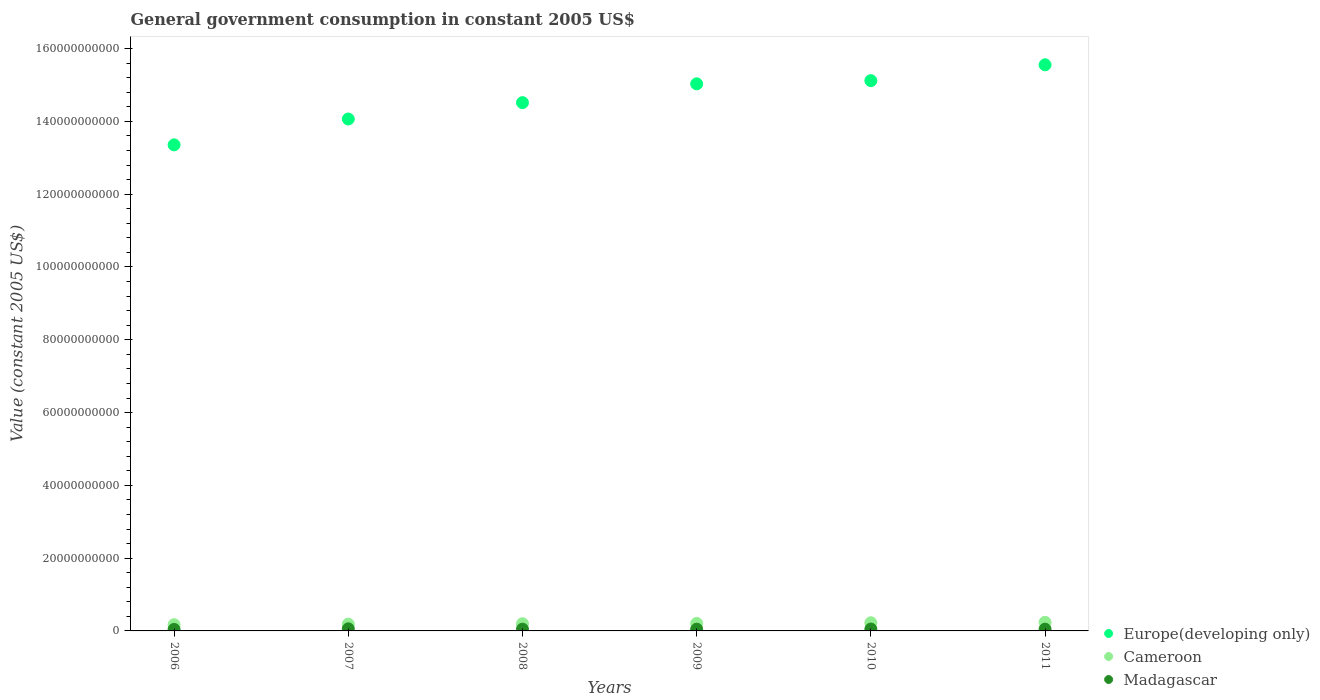Is the number of dotlines equal to the number of legend labels?
Make the answer very short. Yes. What is the government conusmption in Cameroon in 2011?
Offer a very short reply. 2.36e+09. Across all years, what is the maximum government conusmption in Madagascar?
Ensure brevity in your answer.  5.80e+08. Across all years, what is the minimum government conusmption in Cameroon?
Provide a short and direct response. 1.70e+09. What is the total government conusmption in Europe(developing only) in the graph?
Your answer should be very brief. 8.76e+11. What is the difference between the government conusmption in Cameroon in 2007 and that in 2008?
Your response must be concise. -1.17e+08. What is the difference between the government conusmption in Cameroon in 2006 and the government conusmption in Europe(developing only) in 2007?
Your answer should be compact. -1.39e+11. What is the average government conusmption in Cameroon per year?
Your answer should be very brief. 2.03e+09. In the year 2008, what is the difference between the government conusmption in Europe(developing only) and government conusmption in Cameroon?
Provide a short and direct response. 1.43e+11. What is the ratio of the government conusmption in Cameroon in 2007 to that in 2010?
Offer a terse response. 0.83. Is the government conusmption in Madagascar in 2008 less than that in 2010?
Your answer should be very brief. Yes. Is the difference between the government conusmption in Europe(developing only) in 2009 and 2010 greater than the difference between the government conusmption in Cameroon in 2009 and 2010?
Offer a very short reply. No. What is the difference between the highest and the second highest government conusmption in Cameroon?
Your response must be concise. 1.22e+08. What is the difference between the highest and the lowest government conusmption in Cameroon?
Ensure brevity in your answer.  6.59e+08. Is the sum of the government conusmption in Cameroon in 2006 and 2008 greater than the maximum government conusmption in Madagascar across all years?
Ensure brevity in your answer.  Yes. Does the government conusmption in Europe(developing only) monotonically increase over the years?
Give a very brief answer. Yes. Is the government conusmption in Cameroon strictly greater than the government conusmption in Europe(developing only) over the years?
Offer a terse response. No. Is the government conusmption in Cameroon strictly less than the government conusmption in Europe(developing only) over the years?
Make the answer very short. Yes. Are the values on the major ticks of Y-axis written in scientific E-notation?
Provide a succinct answer. No. What is the title of the graph?
Your response must be concise. General government consumption in constant 2005 US$. Does "Faeroe Islands" appear as one of the legend labels in the graph?
Provide a short and direct response. No. What is the label or title of the Y-axis?
Ensure brevity in your answer.  Value (constant 2005 US$). What is the Value (constant 2005 US$) of Europe(developing only) in 2006?
Keep it short and to the point. 1.34e+11. What is the Value (constant 2005 US$) in Cameroon in 2006?
Your response must be concise. 1.70e+09. What is the Value (constant 2005 US$) of Madagascar in 2006?
Ensure brevity in your answer.  4.10e+08. What is the Value (constant 2005 US$) of Europe(developing only) in 2007?
Provide a succinct answer. 1.41e+11. What is the Value (constant 2005 US$) of Cameroon in 2007?
Your answer should be compact. 1.86e+09. What is the Value (constant 2005 US$) in Madagascar in 2007?
Give a very brief answer. 5.80e+08. What is the Value (constant 2005 US$) of Europe(developing only) in 2008?
Keep it short and to the point. 1.45e+11. What is the Value (constant 2005 US$) of Cameroon in 2008?
Offer a terse response. 1.97e+09. What is the Value (constant 2005 US$) of Madagascar in 2008?
Provide a short and direct response. 4.82e+08. What is the Value (constant 2005 US$) of Europe(developing only) in 2009?
Ensure brevity in your answer.  1.50e+11. What is the Value (constant 2005 US$) in Cameroon in 2009?
Provide a short and direct response. 2.07e+09. What is the Value (constant 2005 US$) in Madagascar in 2009?
Your response must be concise. 4.81e+08. What is the Value (constant 2005 US$) in Europe(developing only) in 2010?
Make the answer very short. 1.51e+11. What is the Value (constant 2005 US$) of Cameroon in 2010?
Offer a very short reply. 2.24e+09. What is the Value (constant 2005 US$) in Madagascar in 2010?
Provide a short and direct response. 5.17e+08. What is the Value (constant 2005 US$) in Europe(developing only) in 2011?
Your answer should be very brief. 1.56e+11. What is the Value (constant 2005 US$) in Cameroon in 2011?
Your response must be concise. 2.36e+09. What is the Value (constant 2005 US$) in Madagascar in 2011?
Offer a terse response. 4.89e+08. Across all years, what is the maximum Value (constant 2005 US$) of Europe(developing only)?
Provide a short and direct response. 1.56e+11. Across all years, what is the maximum Value (constant 2005 US$) in Cameroon?
Your answer should be very brief. 2.36e+09. Across all years, what is the maximum Value (constant 2005 US$) of Madagascar?
Give a very brief answer. 5.80e+08. Across all years, what is the minimum Value (constant 2005 US$) of Europe(developing only)?
Offer a terse response. 1.34e+11. Across all years, what is the minimum Value (constant 2005 US$) in Cameroon?
Your answer should be very brief. 1.70e+09. Across all years, what is the minimum Value (constant 2005 US$) in Madagascar?
Keep it short and to the point. 4.10e+08. What is the total Value (constant 2005 US$) in Europe(developing only) in the graph?
Your answer should be very brief. 8.76e+11. What is the total Value (constant 2005 US$) of Cameroon in the graph?
Your response must be concise. 1.22e+1. What is the total Value (constant 2005 US$) of Madagascar in the graph?
Your answer should be compact. 2.96e+09. What is the difference between the Value (constant 2005 US$) of Europe(developing only) in 2006 and that in 2007?
Offer a terse response. -7.10e+09. What is the difference between the Value (constant 2005 US$) of Cameroon in 2006 and that in 2007?
Make the answer very short. -1.54e+08. What is the difference between the Value (constant 2005 US$) of Madagascar in 2006 and that in 2007?
Keep it short and to the point. -1.70e+08. What is the difference between the Value (constant 2005 US$) of Europe(developing only) in 2006 and that in 2008?
Your answer should be very brief. -1.16e+1. What is the difference between the Value (constant 2005 US$) in Cameroon in 2006 and that in 2008?
Your answer should be very brief. -2.72e+08. What is the difference between the Value (constant 2005 US$) of Madagascar in 2006 and that in 2008?
Your answer should be compact. -7.20e+07. What is the difference between the Value (constant 2005 US$) in Europe(developing only) in 2006 and that in 2009?
Your response must be concise. -1.68e+1. What is the difference between the Value (constant 2005 US$) of Cameroon in 2006 and that in 2009?
Ensure brevity in your answer.  -3.63e+08. What is the difference between the Value (constant 2005 US$) in Madagascar in 2006 and that in 2009?
Your answer should be very brief. -7.07e+07. What is the difference between the Value (constant 2005 US$) of Europe(developing only) in 2006 and that in 2010?
Your response must be concise. -1.76e+1. What is the difference between the Value (constant 2005 US$) in Cameroon in 2006 and that in 2010?
Give a very brief answer. -5.36e+08. What is the difference between the Value (constant 2005 US$) of Madagascar in 2006 and that in 2010?
Give a very brief answer. -1.07e+08. What is the difference between the Value (constant 2005 US$) in Europe(developing only) in 2006 and that in 2011?
Give a very brief answer. -2.20e+1. What is the difference between the Value (constant 2005 US$) in Cameroon in 2006 and that in 2011?
Make the answer very short. -6.59e+08. What is the difference between the Value (constant 2005 US$) of Madagascar in 2006 and that in 2011?
Ensure brevity in your answer.  -7.88e+07. What is the difference between the Value (constant 2005 US$) of Europe(developing only) in 2007 and that in 2008?
Your response must be concise. -4.50e+09. What is the difference between the Value (constant 2005 US$) of Cameroon in 2007 and that in 2008?
Provide a short and direct response. -1.17e+08. What is the difference between the Value (constant 2005 US$) of Madagascar in 2007 and that in 2008?
Your response must be concise. 9.81e+07. What is the difference between the Value (constant 2005 US$) of Europe(developing only) in 2007 and that in 2009?
Offer a terse response. -9.67e+09. What is the difference between the Value (constant 2005 US$) in Cameroon in 2007 and that in 2009?
Your answer should be compact. -2.09e+08. What is the difference between the Value (constant 2005 US$) in Madagascar in 2007 and that in 2009?
Keep it short and to the point. 9.94e+07. What is the difference between the Value (constant 2005 US$) of Europe(developing only) in 2007 and that in 2010?
Keep it short and to the point. -1.05e+1. What is the difference between the Value (constant 2005 US$) in Cameroon in 2007 and that in 2010?
Offer a very short reply. -3.82e+08. What is the difference between the Value (constant 2005 US$) in Madagascar in 2007 and that in 2010?
Give a very brief answer. 6.27e+07. What is the difference between the Value (constant 2005 US$) of Europe(developing only) in 2007 and that in 2011?
Give a very brief answer. -1.49e+1. What is the difference between the Value (constant 2005 US$) in Cameroon in 2007 and that in 2011?
Offer a very short reply. -5.04e+08. What is the difference between the Value (constant 2005 US$) in Madagascar in 2007 and that in 2011?
Your answer should be compact. 9.14e+07. What is the difference between the Value (constant 2005 US$) of Europe(developing only) in 2008 and that in 2009?
Ensure brevity in your answer.  -5.17e+09. What is the difference between the Value (constant 2005 US$) in Cameroon in 2008 and that in 2009?
Your answer should be compact. -9.13e+07. What is the difference between the Value (constant 2005 US$) of Madagascar in 2008 and that in 2009?
Keep it short and to the point. 1.31e+06. What is the difference between the Value (constant 2005 US$) of Europe(developing only) in 2008 and that in 2010?
Give a very brief answer. -6.04e+09. What is the difference between the Value (constant 2005 US$) of Cameroon in 2008 and that in 2010?
Provide a succinct answer. -2.65e+08. What is the difference between the Value (constant 2005 US$) in Madagascar in 2008 and that in 2010?
Your answer should be compact. -3.54e+07. What is the difference between the Value (constant 2005 US$) in Europe(developing only) in 2008 and that in 2011?
Keep it short and to the point. -1.04e+1. What is the difference between the Value (constant 2005 US$) of Cameroon in 2008 and that in 2011?
Your answer should be very brief. -3.87e+08. What is the difference between the Value (constant 2005 US$) of Madagascar in 2008 and that in 2011?
Provide a short and direct response. -6.71e+06. What is the difference between the Value (constant 2005 US$) in Europe(developing only) in 2009 and that in 2010?
Your answer should be compact. -8.73e+08. What is the difference between the Value (constant 2005 US$) of Cameroon in 2009 and that in 2010?
Your answer should be very brief. -1.73e+08. What is the difference between the Value (constant 2005 US$) of Madagascar in 2009 and that in 2010?
Provide a short and direct response. -3.68e+07. What is the difference between the Value (constant 2005 US$) in Europe(developing only) in 2009 and that in 2011?
Ensure brevity in your answer.  -5.23e+09. What is the difference between the Value (constant 2005 US$) in Cameroon in 2009 and that in 2011?
Provide a succinct answer. -2.96e+08. What is the difference between the Value (constant 2005 US$) of Madagascar in 2009 and that in 2011?
Make the answer very short. -8.02e+06. What is the difference between the Value (constant 2005 US$) in Europe(developing only) in 2010 and that in 2011?
Offer a terse response. -4.36e+09. What is the difference between the Value (constant 2005 US$) of Cameroon in 2010 and that in 2011?
Make the answer very short. -1.22e+08. What is the difference between the Value (constant 2005 US$) of Madagascar in 2010 and that in 2011?
Make the answer very short. 2.87e+07. What is the difference between the Value (constant 2005 US$) of Europe(developing only) in 2006 and the Value (constant 2005 US$) of Cameroon in 2007?
Ensure brevity in your answer.  1.32e+11. What is the difference between the Value (constant 2005 US$) in Europe(developing only) in 2006 and the Value (constant 2005 US$) in Madagascar in 2007?
Give a very brief answer. 1.33e+11. What is the difference between the Value (constant 2005 US$) in Cameroon in 2006 and the Value (constant 2005 US$) in Madagascar in 2007?
Make the answer very short. 1.12e+09. What is the difference between the Value (constant 2005 US$) of Europe(developing only) in 2006 and the Value (constant 2005 US$) of Cameroon in 2008?
Your response must be concise. 1.32e+11. What is the difference between the Value (constant 2005 US$) in Europe(developing only) in 2006 and the Value (constant 2005 US$) in Madagascar in 2008?
Keep it short and to the point. 1.33e+11. What is the difference between the Value (constant 2005 US$) in Cameroon in 2006 and the Value (constant 2005 US$) in Madagascar in 2008?
Your answer should be compact. 1.22e+09. What is the difference between the Value (constant 2005 US$) of Europe(developing only) in 2006 and the Value (constant 2005 US$) of Cameroon in 2009?
Offer a terse response. 1.31e+11. What is the difference between the Value (constant 2005 US$) in Europe(developing only) in 2006 and the Value (constant 2005 US$) in Madagascar in 2009?
Make the answer very short. 1.33e+11. What is the difference between the Value (constant 2005 US$) of Cameroon in 2006 and the Value (constant 2005 US$) of Madagascar in 2009?
Give a very brief answer. 1.22e+09. What is the difference between the Value (constant 2005 US$) in Europe(developing only) in 2006 and the Value (constant 2005 US$) in Cameroon in 2010?
Ensure brevity in your answer.  1.31e+11. What is the difference between the Value (constant 2005 US$) in Europe(developing only) in 2006 and the Value (constant 2005 US$) in Madagascar in 2010?
Offer a terse response. 1.33e+11. What is the difference between the Value (constant 2005 US$) in Cameroon in 2006 and the Value (constant 2005 US$) in Madagascar in 2010?
Offer a terse response. 1.18e+09. What is the difference between the Value (constant 2005 US$) in Europe(developing only) in 2006 and the Value (constant 2005 US$) in Cameroon in 2011?
Provide a short and direct response. 1.31e+11. What is the difference between the Value (constant 2005 US$) of Europe(developing only) in 2006 and the Value (constant 2005 US$) of Madagascar in 2011?
Offer a terse response. 1.33e+11. What is the difference between the Value (constant 2005 US$) of Cameroon in 2006 and the Value (constant 2005 US$) of Madagascar in 2011?
Make the answer very short. 1.21e+09. What is the difference between the Value (constant 2005 US$) of Europe(developing only) in 2007 and the Value (constant 2005 US$) of Cameroon in 2008?
Provide a succinct answer. 1.39e+11. What is the difference between the Value (constant 2005 US$) in Europe(developing only) in 2007 and the Value (constant 2005 US$) in Madagascar in 2008?
Ensure brevity in your answer.  1.40e+11. What is the difference between the Value (constant 2005 US$) of Cameroon in 2007 and the Value (constant 2005 US$) of Madagascar in 2008?
Ensure brevity in your answer.  1.37e+09. What is the difference between the Value (constant 2005 US$) in Europe(developing only) in 2007 and the Value (constant 2005 US$) in Cameroon in 2009?
Your answer should be very brief. 1.39e+11. What is the difference between the Value (constant 2005 US$) of Europe(developing only) in 2007 and the Value (constant 2005 US$) of Madagascar in 2009?
Offer a very short reply. 1.40e+11. What is the difference between the Value (constant 2005 US$) of Cameroon in 2007 and the Value (constant 2005 US$) of Madagascar in 2009?
Your answer should be very brief. 1.38e+09. What is the difference between the Value (constant 2005 US$) in Europe(developing only) in 2007 and the Value (constant 2005 US$) in Cameroon in 2010?
Your answer should be compact. 1.38e+11. What is the difference between the Value (constant 2005 US$) of Europe(developing only) in 2007 and the Value (constant 2005 US$) of Madagascar in 2010?
Offer a very short reply. 1.40e+11. What is the difference between the Value (constant 2005 US$) of Cameroon in 2007 and the Value (constant 2005 US$) of Madagascar in 2010?
Your response must be concise. 1.34e+09. What is the difference between the Value (constant 2005 US$) in Europe(developing only) in 2007 and the Value (constant 2005 US$) in Cameroon in 2011?
Your response must be concise. 1.38e+11. What is the difference between the Value (constant 2005 US$) of Europe(developing only) in 2007 and the Value (constant 2005 US$) of Madagascar in 2011?
Offer a terse response. 1.40e+11. What is the difference between the Value (constant 2005 US$) of Cameroon in 2007 and the Value (constant 2005 US$) of Madagascar in 2011?
Ensure brevity in your answer.  1.37e+09. What is the difference between the Value (constant 2005 US$) of Europe(developing only) in 2008 and the Value (constant 2005 US$) of Cameroon in 2009?
Ensure brevity in your answer.  1.43e+11. What is the difference between the Value (constant 2005 US$) in Europe(developing only) in 2008 and the Value (constant 2005 US$) in Madagascar in 2009?
Your answer should be very brief. 1.45e+11. What is the difference between the Value (constant 2005 US$) in Cameroon in 2008 and the Value (constant 2005 US$) in Madagascar in 2009?
Keep it short and to the point. 1.49e+09. What is the difference between the Value (constant 2005 US$) in Europe(developing only) in 2008 and the Value (constant 2005 US$) in Cameroon in 2010?
Offer a very short reply. 1.43e+11. What is the difference between the Value (constant 2005 US$) of Europe(developing only) in 2008 and the Value (constant 2005 US$) of Madagascar in 2010?
Give a very brief answer. 1.45e+11. What is the difference between the Value (constant 2005 US$) in Cameroon in 2008 and the Value (constant 2005 US$) in Madagascar in 2010?
Offer a terse response. 1.46e+09. What is the difference between the Value (constant 2005 US$) of Europe(developing only) in 2008 and the Value (constant 2005 US$) of Cameroon in 2011?
Make the answer very short. 1.43e+11. What is the difference between the Value (constant 2005 US$) in Europe(developing only) in 2008 and the Value (constant 2005 US$) in Madagascar in 2011?
Provide a short and direct response. 1.45e+11. What is the difference between the Value (constant 2005 US$) in Cameroon in 2008 and the Value (constant 2005 US$) in Madagascar in 2011?
Offer a very short reply. 1.49e+09. What is the difference between the Value (constant 2005 US$) in Europe(developing only) in 2009 and the Value (constant 2005 US$) in Cameroon in 2010?
Provide a short and direct response. 1.48e+11. What is the difference between the Value (constant 2005 US$) of Europe(developing only) in 2009 and the Value (constant 2005 US$) of Madagascar in 2010?
Offer a very short reply. 1.50e+11. What is the difference between the Value (constant 2005 US$) of Cameroon in 2009 and the Value (constant 2005 US$) of Madagascar in 2010?
Make the answer very short. 1.55e+09. What is the difference between the Value (constant 2005 US$) in Europe(developing only) in 2009 and the Value (constant 2005 US$) in Cameroon in 2011?
Your answer should be compact. 1.48e+11. What is the difference between the Value (constant 2005 US$) in Europe(developing only) in 2009 and the Value (constant 2005 US$) in Madagascar in 2011?
Offer a very short reply. 1.50e+11. What is the difference between the Value (constant 2005 US$) of Cameroon in 2009 and the Value (constant 2005 US$) of Madagascar in 2011?
Ensure brevity in your answer.  1.58e+09. What is the difference between the Value (constant 2005 US$) in Europe(developing only) in 2010 and the Value (constant 2005 US$) in Cameroon in 2011?
Provide a short and direct response. 1.49e+11. What is the difference between the Value (constant 2005 US$) of Europe(developing only) in 2010 and the Value (constant 2005 US$) of Madagascar in 2011?
Provide a short and direct response. 1.51e+11. What is the difference between the Value (constant 2005 US$) in Cameroon in 2010 and the Value (constant 2005 US$) in Madagascar in 2011?
Ensure brevity in your answer.  1.75e+09. What is the average Value (constant 2005 US$) of Europe(developing only) per year?
Make the answer very short. 1.46e+11. What is the average Value (constant 2005 US$) in Cameroon per year?
Give a very brief answer. 2.03e+09. What is the average Value (constant 2005 US$) of Madagascar per year?
Make the answer very short. 4.93e+08. In the year 2006, what is the difference between the Value (constant 2005 US$) in Europe(developing only) and Value (constant 2005 US$) in Cameroon?
Provide a succinct answer. 1.32e+11. In the year 2006, what is the difference between the Value (constant 2005 US$) of Europe(developing only) and Value (constant 2005 US$) of Madagascar?
Your response must be concise. 1.33e+11. In the year 2006, what is the difference between the Value (constant 2005 US$) in Cameroon and Value (constant 2005 US$) in Madagascar?
Keep it short and to the point. 1.29e+09. In the year 2007, what is the difference between the Value (constant 2005 US$) in Europe(developing only) and Value (constant 2005 US$) in Cameroon?
Your answer should be very brief. 1.39e+11. In the year 2007, what is the difference between the Value (constant 2005 US$) in Europe(developing only) and Value (constant 2005 US$) in Madagascar?
Your answer should be compact. 1.40e+11. In the year 2007, what is the difference between the Value (constant 2005 US$) of Cameroon and Value (constant 2005 US$) of Madagascar?
Your response must be concise. 1.28e+09. In the year 2008, what is the difference between the Value (constant 2005 US$) in Europe(developing only) and Value (constant 2005 US$) in Cameroon?
Offer a very short reply. 1.43e+11. In the year 2008, what is the difference between the Value (constant 2005 US$) of Europe(developing only) and Value (constant 2005 US$) of Madagascar?
Give a very brief answer. 1.45e+11. In the year 2008, what is the difference between the Value (constant 2005 US$) of Cameroon and Value (constant 2005 US$) of Madagascar?
Keep it short and to the point. 1.49e+09. In the year 2009, what is the difference between the Value (constant 2005 US$) in Europe(developing only) and Value (constant 2005 US$) in Cameroon?
Keep it short and to the point. 1.48e+11. In the year 2009, what is the difference between the Value (constant 2005 US$) in Europe(developing only) and Value (constant 2005 US$) in Madagascar?
Provide a short and direct response. 1.50e+11. In the year 2009, what is the difference between the Value (constant 2005 US$) in Cameroon and Value (constant 2005 US$) in Madagascar?
Ensure brevity in your answer.  1.58e+09. In the year 2010, what is the difference between the Value (constant 2005 US$) in Europe(developing only) and Value (constant 2005 US$) in Cameroon?
Your response must be concise. 1.49e+11. In the year 2010, what is the difference between the Value (constant 2005 US$) of Europe(developing only) and Value (constant 2005 US$) of Madagascar?
Provide a succinct answer. 1.51e+11. In the year 2010, what is the difference between the Value (constant 2005 US$) of Cameroon and Value (constant 2005 US$) of Madagascar?
Give a very brief answer. 1.72e+09. In the year 2011, what is the difference between the Value (constant 2005 US$) in Europe(developing only) and Value (constant 2005 US$) in Cameroon?
Offer a terse response. 1.53e+11. In the year 2011, what is the difference between the Value (constant 2005 US$) of Europe(developing only) and Value (constant 2005 US$) of Madagascar?
Provide a short and direct response. 1.55e+11. In the year 2011, what is the difference between the Value (constant 2005 US$) of Cameroon and Value (constant 2005 US$) of Madagascar?
Your response must be concise. 1.87e+09. What is the ratio of the Value (constant 2005 US$) of Europe(developing only) in 2006 to that in 2007?
Provide a succinct answer. 0.95. What is the ratio of the Value (constant 2005 US$) of Cameroon in 2006 to that in 2007?
Your answer should be compact. 0.92. What is the ratio of the Value (constant 2005 US$) of Madagascar in 2006 to that in 2007?
Your answer should be very brief. 0.71. What is the ratio of the Value (constant 2005 US$) in Europe(developing only) in 2006 to that in 2008?
Your answer should be compact. 0.92. What is the ratio of the Value (constant 2005 US$) of Cameroon in 2006 to that in 2008?
Your answer should be very brief. 0.86. What is the ratio of the Value (constant 2005 US$) in Madagascar in 2006 to that in 2008?
Ensure brevity in your answer.  0.85. What is the ratio of the Value (constant 2005 US$) in Europe(developing only) in 2006 to that in 2009?
Provide a succinct answer. 0.89. What is the ratio of the Value (constant 2005 US$) in Cameroon in 2006 to that in 2009?
Provide a succinct answer. 0.82. What is the ratio of the Value (constant 2005 US$) in Madagascar in 2006 to that in 2009?
Give a very brief answer. 0.85. What is the ratio of the Value (constant 2005 US$) of Europe(developing only) in 2006 to that in 2010?
Your answer should be very brief. 0.88. What is the ratio of the Value (constant 2005 US$) of Cameroon in 2006 to that in 2010?
Offer a very short reply. 0.76. What is the ratio of the Value (constant 2005 US$) of Madagascar in 2006 to that in 2010?
Ensure brevity in your answer.  0.79. What is the ratio of the Value (constant 2005 US$) in Europe(developing only) in 2006 to that in 2011?
Provide a short and direct response. 0.86. What is the ratio of the Value (constant 2005 US$) in Cameroon in 2006 to that in 2011?
Make the answer very short. 0.72. What is the ratio of the Value (constant 2005 US$) of Madagascar in 2006 to that in 2011?
Your response must be concise. 0.84. What is the ratio of the Value (constant 2005 US$) of Cameroon in 2007 to that in 2008?
Provide a succinct answer. 0.94. What is the ratio of the Value (constant 2005 US$) in Madagascar in 2007 to that in 2008?
Give a very brief answer. 1.2. What is the ratio of the Value (constant 2005 US$) in Europe(developing only) in 2007 to that in 2009?
Make the answer very short. 0.94. What is the ratio of the Value (constant 2005 US$) of Cameroon in 2007 to that in 2009?
Ensure brevity in your answer.  0.9. What is the ratio of the Value (constant 2005 US$) of Madagascar in 2007 to that in 2009?
Provide a succinct answer. 1.21. What is the ratio of the Value (constant 2005 US$) in Europe(developing only) in 2007 to that in 2010?
Ensure brevity in your answer.  0.93. What is the ratio of the Value (constant 2005 US$) of Cameroon in 2007 to that in 2010?
Keep it short and to the point. 0.83. What is the ratio of the Value (constant 2005 US$) of Madagascar in 2007 to that in 2010?
Ensure brevity in your answer.  1.12. What is the ratio of the Value (constant 2005 US$) in Europe(developing only) in 2007 to that in 2011?
Provide a succinct answer. 0.9. What is the ratio of the Value (constant 2005 US$) in Cameroon in 2007 to that in 2011?
Keep it short and to the point. 0.79. What is the ratio of the Value (constant 2005 US$) in Madagascar in 2007 to that in 2011?
Give a very brief answer. 1.19. What is the ratio of the Value (constant 2005 US$) of Europe(developing only) in 2008 to that in 2009?
Your answer should be very brief. 0.97. What is the ratio of the Value (constant 2005 US$) of Cameroon in 2008 to that in 2009?
Give a very brief answer. 0.96. What is the ratio of the Value (constant 2005 US$) of Madagascar in 2008 to that in 2009?
Your answer should be compact. 1. What is the ratio of the Value (constant 2005 US$) in Europe(developing only) in 2008 to that in 2010?
Ensure brevity in your answer.  0.96. What is the ratio of the Value (constant 2005 US$) in Cameroon in 2008 to that in 2010?
Your response must be concise. 0.88. What is the ratio of the Value (constant 2005 US$) in Madagascar in 2008 to that in 2010?
Provide a succinct answer. 0.93. What is the ratio of the Value (constant 2005 US$) in Europe(developing only) in 2008 to that in 2011?
Provide a short and direct response. 0.93. What is the ratio of the Value (constant 2005 US$) of Cameroon in 2008 to that in 2011?
Ensure brevity in your answer.  0.84. What is the ratio of the Value (constant 2005 US$) in Madagascar in 2008 to that in 2011?
Provide a succinct answer. 0.99. What is the ratio of the Value (constant 2005 US$) of Europe(developing only) in 2009 to that in 2010?
Give a very brief answer. 0.99. What is the ratio of the Value (constant 2005 US$) of Cameroon in 2009 to that in 2010?
Offer a very short reply. 0.92. What is the ratio of the Value (constant 2005 US$) in Madagascar in 2009 to that in 2010?
Your answer should be compact. 0.93. What is the ratio of the Value (constant 2005 US$) of Europe(developing only) in 2009 to that in 2011?
Keep it short and to the point. 0.97. What is the ratio of the Value (constant 2005 US$) in Cameroon in 2009 to that in 2011?
Give a very brief answer. 0.87. What is the ratio of the Value (constant 2005 US$) of Madagascar in 2009 to that in 2011?
Keep it short and to the point. 0.98. What is the ratio of the Value (constant 2005 US$) of Europe(developing only) in 2010 to that in 2011?
Offer a very short reply. 0.97. What is the ratio of the Value (constant 2005 US$) of Cameroon in 2010 to that in 2011?
Provide a succinct answer. 0.95. What is the ratio of the Value (constant 2005 US$) in Madagascar in 2010 to that in 2011?
Keep it short and to the point. 1.06. What is the difference between the highest and the second highest Value (constant 2005 US$) of Europe(developing only)?
Give a very brief answer. 4.36e+09. What is the difference between the highest and the second highest Value (constant 2005 US$) of Cameroon?
Keep it short and to the point. 1.22e+08. What is the difference between the highest and the second highest Value (constant 2005 US$) of Madagascar?
Make the answer very short. 6.27e+07. What is the difference between the highest and the lowest Value (constant 2005 US$) of Europe(developing only)?
Offer a very short reply. 2.20e+1. What is the difference between the highest and the lowest Value (constant 2005 US$) in Cameroon?
Provide a short and direct response. 6.59e+08. What is the difference between the highest and the lowest Value (constant 2005 US$) of Madagascar?
Give a very brief answer. 1.70e+08. 